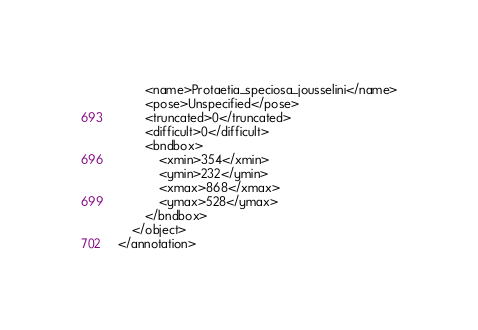<code> <loc_0><loc_0><loc_500><loc_500><_XML_>		<name>Protaetia_speciosa_jousselini</name>
		<pose>Unspecified</pose>
		<truncated>0</truncated>
		<difficult>0</difficult>
		<bndbox>
			<xmin>354</xmin>
			<ymin>232</ymin>
			<xmax>868</xmax>
			<ymax>528</ymax>
		</bndbox>
	</object>
</annotation>
</code> 